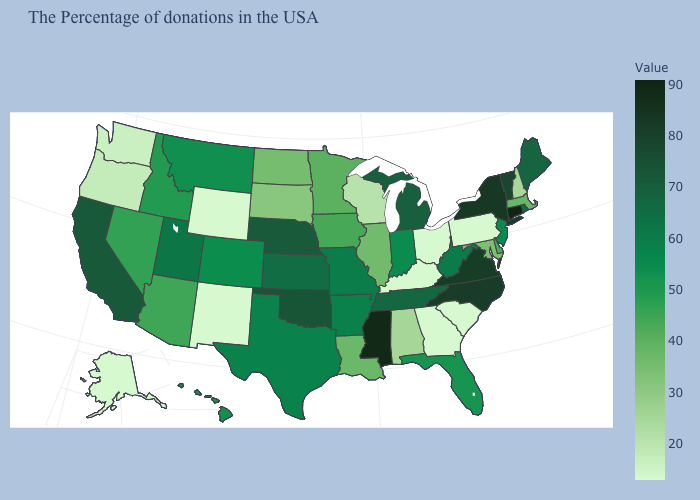Among the states that border West Virginia , does Virginia have the highest value?
Quick response, please. Yes. Does Connecticut have the lowest value in the Northeast?
Keep it brief. No. Is the legend a continuous bar?
Keep it brief. Yes. Which states hav the highest value in the South?
Be succinct. Mississippi. Which states have the lowest value in the USA?
Give a very brief answer. Pennsylvania, South Carolina, Ohio, Georgia, Kentucky, Wyoming, New Mexico, Alaska. 